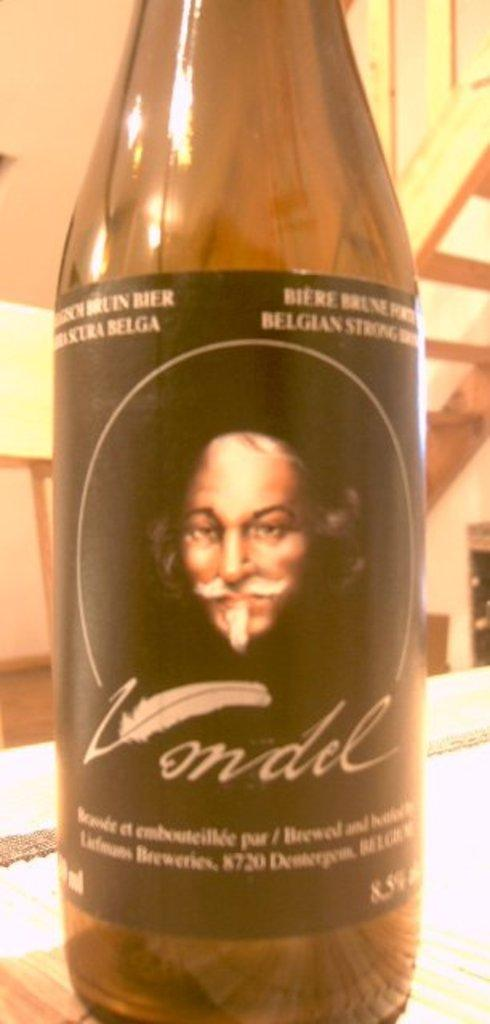<image>
Share a concise interpretation of the image provided. A bottle of Vondel features a picture of a man with a mustache and goatee. 